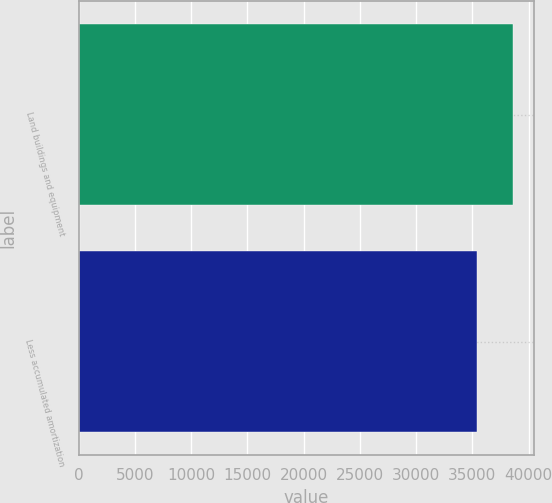Convert chart. <chart><loc_0><loc_0><loc_500><loc_500><bar_chart><fcel>Land buildings and equipment<fcel>Less accumulated amortization<nl><fcel>38584<fcel>35446<nl></chart> 